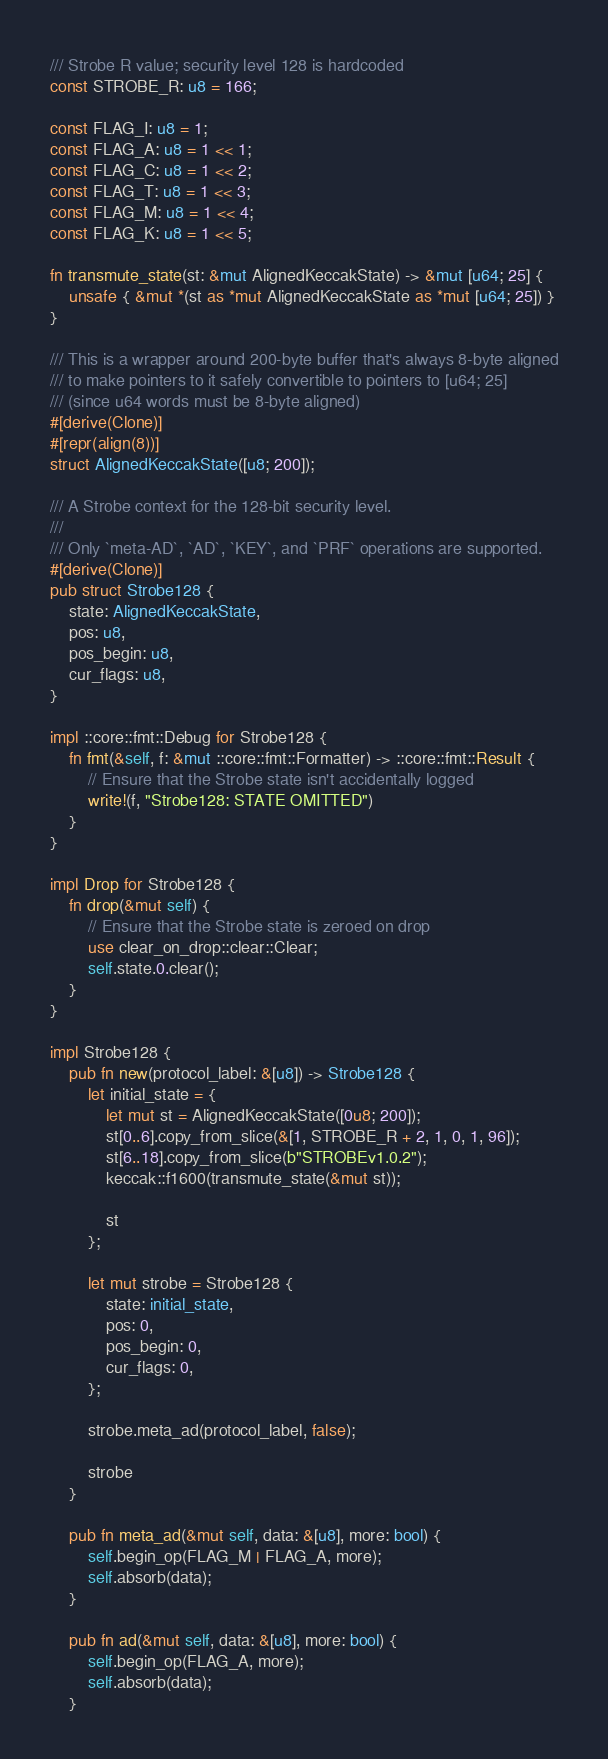<code> <loc_0><loc_0><loc_500><loc_500><_Rust_>/// Strobe R value; security level 128 is hardcoded
const STROBE_R: u8 = 166;

const FLAG_I: u8 = 1;
const FLAG_A: u8 = 1 << 1;
const FLAG_C: u8 = 1 << 2;
const FLAG_T: u8 = 1 << 3;
const FLAG_M: u8 = 1 << 4;
const FLAG_K: u8 = 1 << 5;

fn transmute_state(st: &mut AlignedKeccakState) -> &mut [u64; 25] {
    unsafe { &mut *(st as *mut AlignedKeccakState as *mut [u64; 25]) }
}

/// This is a wrapper around 200-byte buffer that's always 8-byte aligned
/// to make pointers to it safely convertible to pointers to [u64; 25]
/// (since u64 words must be 8-byte aligned)
#[derive(Clone)]
#[repr(align(8))]
struct AlignedKeccakState([u8; 200]);

/// A Strobe context for the 128-bit security level.
///
/// Only `meta-AD`, `AD`, `KEY`, and `PRF` operations are supported.
#[derive(Clone)]
pub struct Strobe128 {
    state: AlignedKeccakState,
    pos: u8,
    pos_begin: u8,
    cur_flags: u8,
}

impl ::core::fmt::Debug for Strobe128 {
    fn fmt(&self, f: &mut ::core::fmt::Formatter) -> ::core::fmt::Result {
        // Ensure that the Strobe state isn't accidentally logged
        write!(f, "Strobe128: STATE OMITTED")
    }
}

impl Drop for Strobe128 {
    fn drop(&mut self) {
        // Ensure that the Strobe state is zeroed on drop
        use clear_on_drop::clear::Clear;
        self.state.0.clear();
    }
}

impl Strobe128 {
    pub fn new(protocol_label: &[u8]) -> Strobe128 {
        let initial_state = {
            let mut st = AlignedKeccakState([0u8; 200]);
            st[0..6].copy_from_slice(&[1, STROBE_R + 2, 1, 0, 1, 96]);
            st[6..18].copy_from_slice(b"STROBEv1.0.2");
            keccak::f1600(transmute_state(&mut st));

            st
        };

        let mut strobe = Strobe128 {
            state: initial_state,
            pos: 0,
            pos_begin: 0,
            cur_flags: 0,
        };

        strobe.meta_ad(protocol_label, false);

        strobe
    }

    pub fn meta_ad(&mut self, data: &[u8], more: bool) {
        self.begin_op(FLAG_M | FLAG_A, more);
        self.absorb(data);
    }

    pub fn ad(&mut self, data: &[u8], more: bool) {
        self.begin_op(FLAG_A, more);
        self.absorb(data);
    }
</code> 